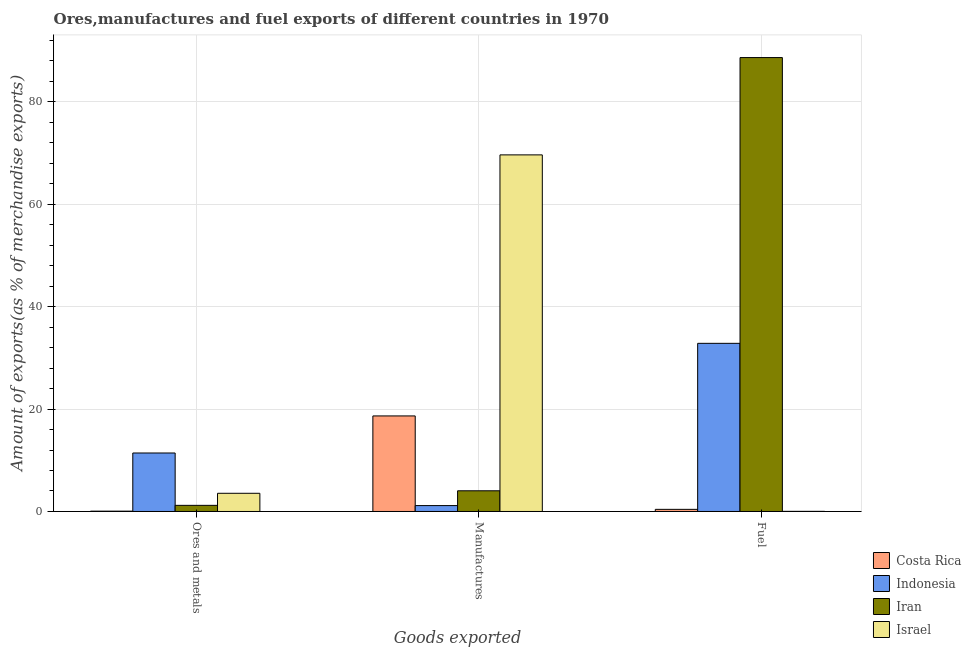How many different coloured bars are there?
Ensure brevity in your answer.  4. Are the number of bars per tick equal to the number of legend labels?
Offer a terse response. Yes. How many bars are there on the 3rd tick from the left?
Provide a short and direct response. 4. What is the label of the 1st group of bars from the left?
Ensure brevity in your answer.  Ores and metals. What is the percentage of manufactures exports in Costa Rica?
Your answer should be very brief. 18.65. Across all countries, what is the maximum percentage of ores and metals exports?
Provide a short and direct response. 11.42. Across all countries, what is the minimum percentage of manufactures exports?
Your response must be concise. 1.15. In which country was the percentage of ores and metals exports maximum?
Offer a terse response. Indonesia. What is the total percentage of manufactures exports in the graph?
Provide a short and direct response. 93.47. What is the difference between the percentage of ores and metals exports in Iran and that in Israel?
Provide a succinct answer. -2.36. What is the difference between the percentage of ores and metals exports in Indonesia and the percentage of fuel exports in Israel?
Provide a short and direct response. 11.39. What is the average percentage of ores and metals exports per country?
Your answer should be very brief. 4.06. What is the difference between the percentage of fuel exports and percentage of manufactures exports in Indonesia?
Keep it short and to the point. 31.67. In how many countries, is the percentage of fuel exports greater than 52 %?
Offer a very short reply. 1. What is the ratio of the percentage of fuel exports in Indonesia to that in Iran?
Make the answer very short. 0.37. Is the percentage of manufactures exports in Israel less than that in Indonesia?
Give a very brief answer. No. Is the difference between the percentage of fuel exports in Costa Rica and Iran greater than the difference between the percentage of manufactures exports in Costa Rica and Iran?
Offer a terse response. No. What is the difference between the highest and the second highest percentage of ores and metals exports?
Your answer should be very brief. 7.87. What is the difference between the highest and the lowest percentage of fuel exports?
Offer a very short reply. 88.59. What does the 3rd bar from the left in Fuel represents?
Your response must be concise. Iran. What does the 4th bar from the right in Ores and metals represents?
Make the answer very short. Costa Rica. How many bars are there?
Your answer should be compact. 12. Are all the bars in the graph horizontal?
Provide a short and direct response. No. How many countries are there in the graph?
Give a very brief answer. 4. What is the difference between two consecutive major ticks on the Y-axis?
Your response must be concise. 20. Are the values on the major ticks of Y-axis written in scientific E-notation?
Give a very brief answer. No. What is the title of the graph?
Provide a short and direct response. Ores,manufactures and fuel exports of different countries in 1970. What is the label or title of the X-axis?
Your answer should be very brief. Goods exported. What is the label or title of the Y-axis?
Make the answer very short. Amount of exports(as % of merchandise exports). What is the Amount of exports(as % of merchandise exports) in Costa Rica in Ores and metals?
Keep it short and to the point. 0.06. What is the Amount of exports(as % of merchandise exports) of Indonesia in Ores and metals?
Offer a very short reply. 11.42. What is the Amount of exports(as % of merchandise exports) of Iran in Ores and metals?
Your answer should be compact. 1.2. What is the Amount of exports(as % of merchandise exports) of Israel in Ores and metals?
Offer a very short reply. 3.55. What is the Amount of exports(as % of merchandise exports) in Costa Rica in Manufactures?
Your response must be concise. 18.65. What is the Amount of exports(as % of merchandise exports) in Indonesia in Manufactures?
Keep it short and to the point. 1.15. What is the Amount of exports(as % of merchandise exports) of Iran in Manufactures?
Make the answer very short. 4.04. What is the Amount of exports(as % of merchandise exports) in Israel in Manufactures?
Provide a succinct answer. 69.62. What is the Amount of exports(as % of merchandise exports) of Costa Rica in Fuel?
Keep it short and to the point. 0.42. What is the Amount of exports(as % of merchandise exports) of Indonesia in Fuel?
Provide a short and direct response. 32.83. What is the Amount of exports(as % of merchandise exports) of Iran in Fuel?
Provide a succinct answer. 88.62. What is the Amount of exports(as % of merchandise exports) of Israel in Fuel?
Give a very brief answer. 0.03. Across all Goods exported, what is the maximum Amount of exports(as % of merchandise exports) of Costa Rica?
Your answer should be compact. 18.65. Across all Goods exported, what is the maximum Amount of exports(as % of merchandise exports) of Indonesia?
Your answer should be compact. 32.83. Across all Goods exported, what is the maximum Amount of exports(as % of merchandise exports) in Iran?
Make the answer very short. 88.62. Across all Goods exported, what is the maximum Amount of exports(as % of merchandise exports) of Israel?
Make the answer very short. 69.62. Across all Goods exported, what is the minimum Amount of exports(as % of merchandise exports) in Costa Rica?
Make the answer very short. 0.06. Across all Goods exported, what is the minimum Amount of exports(as % of merchandise exports) of Indonesia?
Your answer should be compact. 1.15. Across all Goods exported, what is the minimum Amount of exports(as % of merchandise exports) of Iran?
Provide a short and direct response. 1.2. Across all Goods exported, what is the minimum Amount of exports(as % of merchandise exports) in Israel?
Provide a succinct answer. 0.03. What is the total Amount of exports(as % of merchandise exports) in Costa Rica in the graph?
Your answer should be very brief. 19.13. What is the total Amount of exports(as % of merchandise exports) of Indonesia in the graph?
Provide a short and direct response. 45.4. What is the total Amount of exports(as % of merchandise exports) of Iran in the graph?
Your answer should be very brief. 93.86. What is the total Amount of exports(as % of merchandise exports) in Israel in the graph?
Offer a very short reply. 73.2. What is the difference between the Amount of exports(as % of merchandise exports) of Costa Rica in Ores and metals and that in Manufactures?
Make the answer very short. -18.59. What is the difference between the Amount of exports(as % of merchandise exports) in Indonesia in Ores and metals and that in Manufactures?
Ensure brevity in your answer.  10.27. What is the difference between the Amount of exports(as % of merchandise exports) in Iran in Ores and metals and that in Manufactures?
Offer a very short reply. -2.84. What is the difference between the Amount of exports(as % of merchandise exports) of Israel in Ores and metals and that in Manufactures?
Give a very brief answer. -66.07. What is the difference between the Amount of exports(as % of merchandise exports) of Costa Rica in Ores and metals and that in Fuel?
Your response must be concise. -0.35. What is the difference between the Amount of exports(as % of merchandise exports) in Indonesia in Ores and metals and that in Fuel?
Your answer should be very brief. -21.41. What is the difference between the Amount of exports(as % of merchandise exports) in Iran in Ores and metals and that in Fuel?
Make the answer very short. -87.42. What is the difference between the Amount of exports(as % of merchandise exports) in Israel in Ores and metals and that in Fuel?
Ensure brevity in your answer.  3.53. What is the difference between the Amount of exports(as % of merchandise exports) in Costa Rica in Manufactures and that in Fuel?
Provide a succinct answer. 18.24. What is the difference between the Amount of exports(as % of merchandise exports) of Indonesia in Manufactures and that in Fuel?
Offer a very short reply. -31.67. What is the difference between the Amount of exports(as % of merchandise exports) in Iran in Manufactures and that in Fuel?
Your answer should be very brief. -84.58. What is the difference between the Amount of exports(as % of merchandise exports) in Israel in Manufactures and that in Fuel?
Give a very brief answer. 69.6. What is the difference between the Amount of exports(as % of merchandise exports) of Costa Rica in Ores and metals and the Amount of exports(as % of merchandise exports) of Indonesia in Manufactures?
Your answer should be very brief. -1.09. What is the difference between the Amount of exports(as % of merchandise exports) in Costa Rica in Ores and metals and the Amount of exports(as % of merchandise exports) in Iran in Manufactures?
Keep it short and to the point. -3.98. What is the difference between the Amount of exports(as % of merchandise exports) of Costa Rica in Ores and metals and the Amount of exports(as % of merchandise exports) of Israel in Manufactures?
Your answer should be compact. -69.56. What is the difference between the Amount of exports(as % of merchandise exports) of Indonesia in Ores and metals and the Amount of exports(as % of merchandise exports) of Iran in Manufactures?
Ensure brevity in your answer.  7.38. What is the difference between the Amount of exports(as % of merchandise exports) in Indonesia in Ores and metals and the Amount of exports(as % of merchandise exports) in Israel in Manufactures?
Offer a terse response. -58.2. What is the difference between the Amount of exports(as % of merchandise exports) in Iran in Ores and metals and the Amount of exports(as % of merchandise exports) in Israel in Manufactures?
Keep it short and to the point. -68.42. What is the difference between the Amount of exports(as % of merchandise exports) in Costa Rica in Ores and metals and the Amount of exports(as % of merchandise exports) in Indonesia in Fuel?
Keep it short and to the point. -32.76. What is the difference between the Amount of exports(as % of merchandise exports) of Costa Rica in Ores and metals and the Amount of exports(as % of merchandise exports) of Iran in Fuel?
Offer a very short reply. -88.56. What is the difference between the Amount of exports(as % of merchandise exports) of Costa Rica in Ores and metals and the Amount of exports(as % of merchandise exports) of Israel in Fuel?
Your response must be concise. 0.04. What is the difference between the Amount of exports(as % of merchandise exports) in Indonesia in Ores and metals and the Amount of exports(as % of merchandise exports) in Iran in Fuel?
Your answer should be compact. -77.2. What is the difference between the Amount of exports(as % of merchandise exports) in Indonesia in Ores and metals and the Amount of exports(as % of merchandise exports) in Israel in Fuel?
Offer a terse response. 11.39. What is the difference between the Amount of exports(as % of merchandise exports) of Iran in Ores and metals and the Amount of exports(as % of merchandise exports) of Israel in Fuel?
Make the answer very short. 1.17. What is the difference between the Amount of exports(as % of merchandise exports) of Costa Rica in Manufactures and the Amount of exports(as % of merchandise exports) of Indonesia in Fuel?
Provide a succinct answer. -14.17. What is the difference between the Amount of exports(as % of merchandise exports) in Costa Rica in Manufactures and the Amount of exports(as % of merchandise exports) in Iran in Fuel?
Offer a very short reply. -69.96. What is the difference between the Amount of exports(as % of merchandise exports) of Costa Rica in Manufactures and the Amount of exports(as % of merchandise exports) of Israel in Fuel?
Provide a short and direct response. 18.63. What is the difference between the Amount of exports(as % of merchandise exports) in Indonesia in Manufactures and the Amount of exports(as % of merchandise exports) in Iran in Fuel?
Make the answer very short. -87.47. What is the difference between the Amount of exports(as % of merchandise exports) in Indonesia in Manufactures and the Amount of exports(as % of merchandise exports) in Israel in Fuel?
Keep it short and to the point. 1.13. What is the difference between the Amount of exports(as % of merchandise exports) of Iran in Manufactures and the Amount of exports(as % of merchandise exports) of Israel in Fuel?
Offer a very short reply. 4.02. What is the average Amount of exports(as % of merchandise exports) in Costa Rica per Goods exported?
Your answer should be compact. 6.38. What is the average Amount of exports(as % of merchandise exports) of Indonesia per Goods exported?
Provide a succinct answer. 15.13. What is the average Amount of exports(as % of merchandise exports) in Iran per Goods exported?
Provide a succinct answer. 31.29. What is the average Amount of exports(as % of merchandise exports) of Israel per Goods exported?
Give a very brief answer. 24.4. What is the difference between the Amount of exports(as % of merchandise exports) of Costa Rica and Amount of exports(as % of merchandise exports) of Indonesia in Ores and metals?
Offer a very short reply. -11.36. What is the difference between the Amount of exports(as % of merchandise exports) of Costa Rica and Amount of exports(as % of merchandise exports) of Iran in Ores and metals?
Provide a short and direct response. -1.14. What is the difference between the Amount of exports(as % of merchandise exports) of Costa Rica and Amount of exports(as % of merchandise exports) of Israel in Ores and metals?
Provide a succinct answer. -3.49. What is the difference between the Amount of exports(as % of merchandise exports) in Indonesia and Amount of exports(as % of merchandise exports) in Iran in Ores and metals?
Make the answer very short. 10.22. What is the difference between the Amount of exports(as % of merchandise exports) in Indonesia and Amount of exports(as % of merchandise exports) in Israel in Ores and metals?
Offer a terse response. 7.87. What is the difference between the Amount of exports(as % of merchandise exports) of Iran and Amount of exports(as % of merchandise exports) of Israel in Ores and metals?
Ensure brevity in your answer.  -2.35. What is the difference between the Amount of exports(as % of merchandise exports) of Costa Rica and Amount of exports(as % of merchandise exports) of Indonesia in Manufactures?
Make the answer very short. 17.5. What is the difference between the Amount of exports(as % of merchandise exports) in Costa Rica and Amount of exports(as % of merchandise exports) in Iran in Manufactures?
Ensure brevity in your answer.  14.61. What is the difference between the Amount of exports(as % of merchandise exports) of Costa Rica and Amount of exports(as % of merchandise exports) of Israel in Manufactures?
Your response must be concise. -50.97. What is the difference between the Amount of exports(as % of merchandise exports) in Indonesia and Amount of exports(as % of merchandise exports) in Iran in Manufactures?
Your answer should be very brief. -2.89. What is the difference between the Amount of exports(as % of merchandise exports) of Indonesia and Amount of exports(as % of merchandise exports) of Israel in Manufactures?
Give a very brief answer. -68.47. What is the difference between the Amount of exports(as % of merchandise exports) of Iran and Amount of exports(as % of merchandise exports) of Israel in Manufactures?
Provide a succinct answer. -65.58. What is the difference between the Amount of exports(as % of merchandise exports) of Costa Rica and Amount of exports(as % of merchandise exports) of Indonesia in Fuel?
Offer a terse response. -32.41. What is the difference between the Amount of exports(as % of merchandise exports) in Costa Rica and Amount of exports(as % of merchandise exports) in Iran in Fuel?
Ensure brevity in your answer.  -88.2. What is the difference between the Amount of exports(as % of merchandise exports) in Costa Rica and Amount of exports(as % of merchandise exports) in Israel in Fuel?
Your answer should be compact. 0.39. What is the difference between the Amount of exports(as % of merchandise exports) in Indonesia and Amount of exports(as % of merchandise exports) in Iran in Fuel?
Give a very brief answer. -55.79. What is the difference between the Amount of exports(as % of merchandise exports) in Indonesia and Amount of exports(as % of merchandise exports) in Israel in Fuel?
Give a very brief answer. 32.8. What is the difference between the Amount of exports(as % of merchandise exports) of Iran and Amount of exports(as % of merchandise exports) of Israel in Fuel?
Make the answer very short. 88.59. What is the ratio of the Amount of exports(as % of merchandise exports) in Costa Rica in Ores and metals to that in Manufactures?
Your answer should be compact. 0. What is the ratio of the Amount of exports(as % of merchandise exports) in Indonesia in Ores and metals to that in Manufactures?
Offer a very short reply. 9.91. What is the ratio of the Amount of exports(as % of merchandise exports) of Iran in Ores and metals to that in Manufactures?
Provide a succinct answer. 0.3. What is the ratio of the Amount of exports(as % of merchandise exports) in Israel in Ores and metals to that in Manufactures?
Give a very brief answer. 0.05. What is the ratio of the Amount of exports(as % of merchandise exports) of Costa Rica in Ores and metals to that in Fuel?
Your answer should be very brief. 0.15. What is the ratio of the Amount of exports(as % of merchandise exports) of Indonesia in Ores and metals to that in Fuel?
Provide a succinct answer. 0.35. What is the ratio of the Amount of exports(as % of merchandise exports) of Iran in Ores and metals to that in Fuel?
Keep it short and to the point. 0.01. What is the ratio of the Amount of exports(as % of merchandise exports) of Israel in Ores and metals to that in Fuel?
Provide a succinct answer. 139.9. What is the ratio of the Amount of exports(as % of merchandise exports) in Costa Rica in Manufactures to that in Fuel?
Provide a succinct answer. 44.78. What is the ratio of the Amount of exports(as % of merchandise exports) of Indonesia in Manufactures to that in Fuel?
Give a very brief answer. 0.04. What is the ratio of the Amount of exports(as % of merchandise exports) in Iran in Manufactures to that in Fuel?
Ensure brevity in your answer.  0.05. What is the ratio of the Amount of exports(as % of merchandise exports) in Israel in Manufactures to that in Fuel?
Give a very brief answer. 2741.08. What is the difference between the highest and the second highest Amount of exports(as % of merchandise exports) in Costa Rica?
Ensure brevity in your answer.  18.24. What is the difference between the highest and the second highest Amount of exports(as % of merchandise exports) in Indonesia?
Provide a succinct answer. 21.41. What is the difference between the highest and the second highest Amount of exports(as % of merchandise exports) of Iran?
Ensure brevity in your answer.  84.58. What is the difference between the highest and the second highest Amount of exports(as % of merchandise exports) of Israel?
Offer a very short reply. 66.07. What is the difference between the highest and the lowest Amount of exports(as % of merchandise exports) of Costa Rica?
Offer a terse response. 18.59. What is the difference between the highest and the lowest Amount of exports(as % of merchandise exports) in Indonesia?
Your response must be concise. 31.67. What is the difference between the highest and the lowest Amount of exports(as % of merchandise exports) of Iran?
Offer a terse response. 87.42. What is the difference between the highest and the lowest Amount of exports(as % of merchandise exports) of Israel?
Your response must be concise. 69.6. 